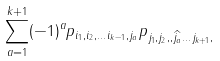<formula> <loc_0><loc_0><loc_500><loc_500>\sum _ { a = 1 } ^ { k + 1 } ( - 1 ) ^ { a } p _ { i _ { 1 } , i _ { 2 } , \dots i _ { k - 1 } , j _ { a } } p _ { j _ { 1 } , j _ { 2 } , , \widehat { j _ { a } } \dots j _ { k + 1 } , }</formula> 